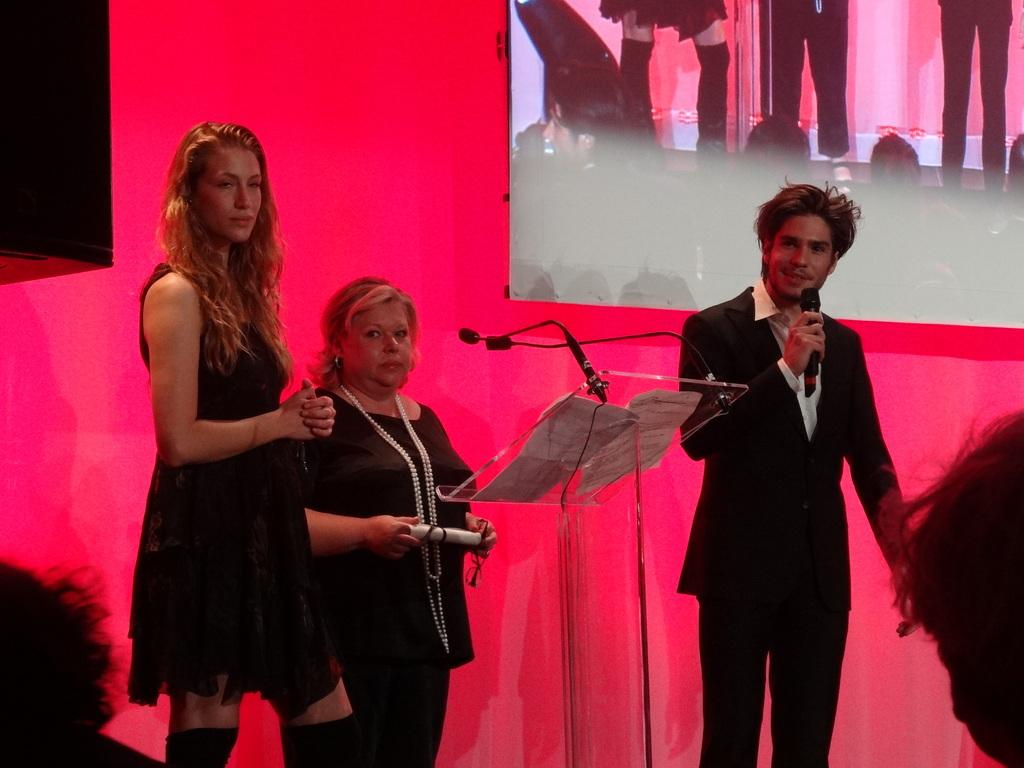What is happening in the image involving the people? There are people standing in the image, which suggests they might be attending an event or gathering. What object is present in the image that is typically used for speeches or presentations? There is a podium in the image, which is commonly used for speeches or presentations. What is the person on the right side of the image holding? The person on the right side of the image is holding a microphone, which is typically used for amplifying sound during speeches or presentations. What is visible in the image that might display information or visuals? There is a screen visible in the image, which can be used to display information or visuals during an event or presentation. What type of breakfast is being served on the podium in the image? There is no breakfast visible in the image, and the podium is not being used for serving food. What color is the spark emitted by the person holding the microphone? There is no spark visible in the image, and the person holding the microphone is not emitting any sparks. 